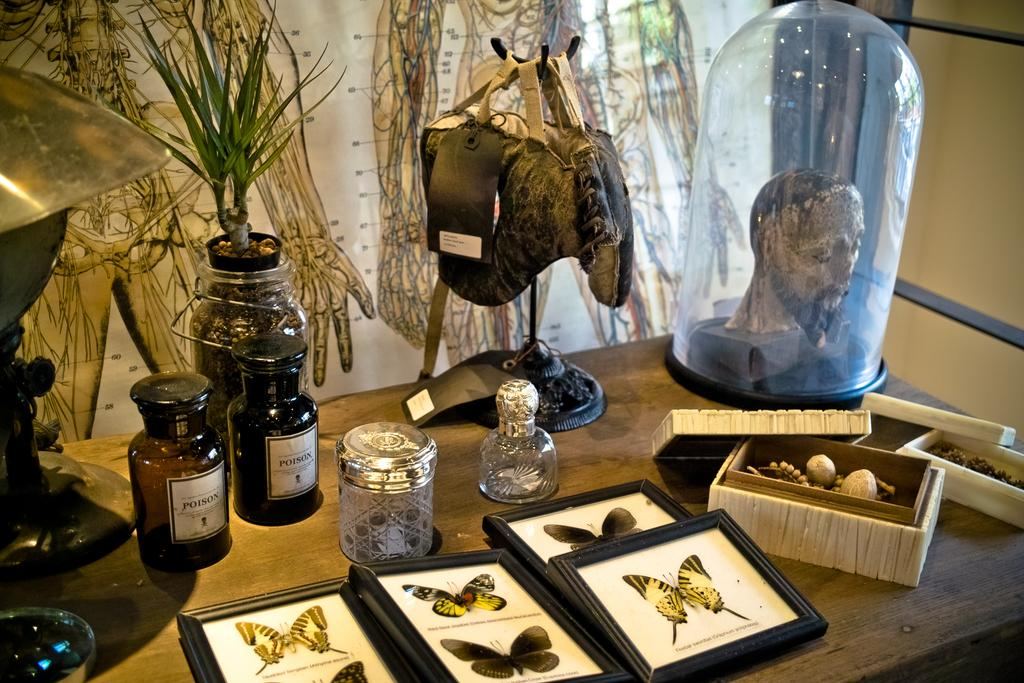What type of furniture is present in the image? There is a table in the image. What items can be seen on the table? There are photo frames, a box, a flower pot, and other objects on the table. What is the purpose of the photo frames? The photo frames are likely used for displaying photographs or artwork. What is the wall in the image used for? The wall provides a background for the table and its contents. What type of visual aid is present in the image? There is a chart in the image. What is the name of the thing that embarks on a voyage in the image? There is no thing embarking on a voyage in the image. What is the significance of the fifth object on the table? There is no mention of a fifth object on the table, so it cannot be determined if it has any significance. 